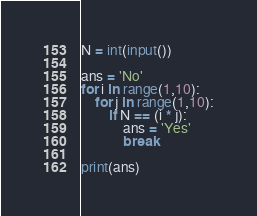<code> <loc_0><loc_0><loc_500><loc_500><_Python_>N = int(input())

ans = 'No'
for i in range(1,10):
    for j in range(1,10):
        if N == (i * j):
            ans = 'Yes'
            break

print(ans)
</code> 